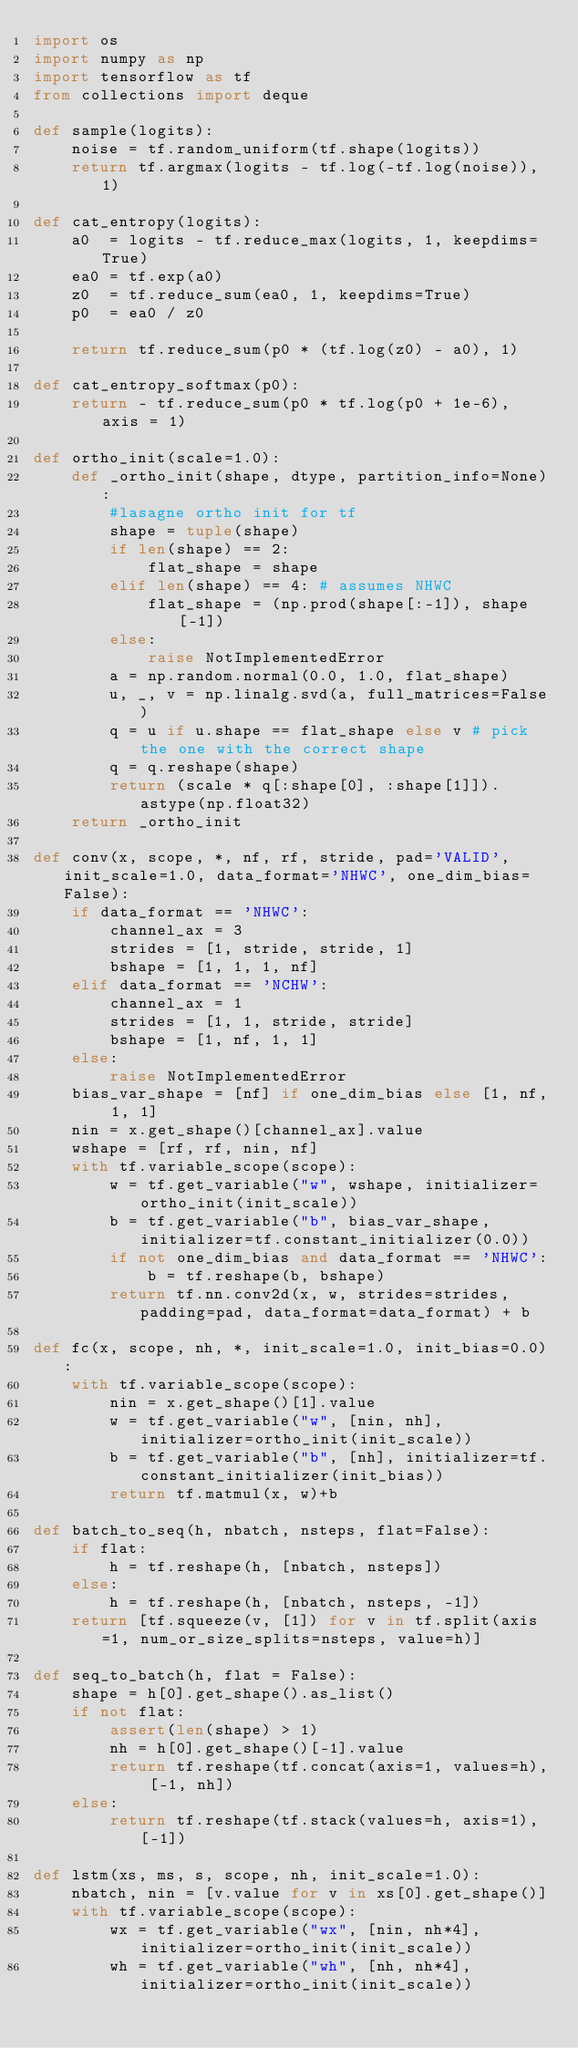<code> <loc_0><loc_0><loc_500><loc_500><_Python_>import os
import numpy as np
import tensorflow as tf
from collections import deque

def sample(logits):
    noise = tf.random_uniform(tf.shape(logits))
    return tf.argmax(logits - tf.log(-tf.log(noise)), 1)

def cat_entropy(logits):
    a0  = logits - tf.reduce_max(logits, 1, keepdims=True)
    ea0 = tf.exp(a0)
    z0  = tf.reduce_sum(ea0, 1, keepdims=True)
    p0  = ea0 / z0

    return tf.reduce_sum(p0 * (tf.log(z0) - a0), 1)

def cat_entropy_softmax(p0):
    return - tf.reduce_sum(p0 * tf.log(p0 + 1e-6), axis = 1)

def ortho_init(scale=1.0):
    def _ortho_init(shape, dtype, partition_info=None):
        #lasagne ortho init for tf
        shape = tuple(shape)
        if len(shape) == 2:
            flat_shape = shape
        elif len(shape) == 4: # assumes NHWC
            flat_shape = (np.prod(shape[:-1]), shape[-1])
        else:
            raise NotImplementedError
        a = np.random.normal(0.0, 1.0, flat_shape)
        u, _, v = np.linalg.svd(a, full_matrices=False)
        q = u if u.shape == flat_shape else v # pick the one with the correct shape
        q = q.reshape(shape)
        return (scale * q[:shape[0], :shape[1]]).astype(np.float32)
    return _ortho_init

def conv(x, scope, *, nf, rf, stride, pad='VALID', init_scale=1.0, data_format='NHWC', one_dim_bias=False):
    if data_format == 'NHWC':
        channel_ax = 3
        strides = [1, stride, stride, 1]
        bshape = [1, 1, 1, nf]
    elif data_format == 'NCHW':
        channel_ax = 1
        strides = [1, 1, stride, stride]
        bshape = [1, nf, 1, 1]
    else:
        raise NotImplementedError
    bias_var_shape = [nf] if one_dim_bias else [1, nf, 1, 1]
    nin = x.get_shape()[channel_ax].value
    wshape = [rf, rf, nin, nf]
    with tf.variable_scope(scope):
        w = tf.get_variable("w", wshape, initializer=ortho_init(init_scale))
        b = tf.get_variable("b", bias_var_shape, initializer=tf.constant_initializer(0.0))
        if not one_dim_bias and data_format == 'NHWC':
            b = tf.reshape(b, bshape)
        return tf.nn.conv2d(x, w, strides=strides, padding=pad, data_format=data_format) + b

def fc(x, scope, nh, *, init_scale=1.0, init_bias=0.0):
    with tf.variable_scope(scope):
        nin = x.get_shape()[1].value
        w = tf.get_variable("w", [nin, nh], initializer=ortho_init(init_scale))
        b = tf.get_variable("b", [nh], initializer=tf.constant_initializer(init_bias))
        return tf.matmul(x, w)+b

def batch_to_seq(h, nbatch, nsteps, flat=False):
    if flat:
        h = tf.reshape(h, [nbatch, nsteps])
    else:
        h = tf.reshape(h, [nbatch, nsteps, -1])
    return [tf.squeeze(v, [1]) for v in tf.split(axis=1, num_or_size_splits=nsteps, value=h)]

def seq_to_batch(h, flat = False):
    shape = h[0].get_shape().as_list()
    if not flat:
        assert(len(shape) > 1)
        nh = h[0].get_shape()[-1].value
        return tf.reshape(tf.concat(axis=1, values=h), [-1, nh])
    else:
        return tf.reshape(tf.stack(values=h, axis=1), [-1])

def lstm(xs, ms, s, scope, nh, init_scale=1.0):
    nbatch, nin = [v.value for v in xs[0].get_shape()]
    with tf.variable_scope(scope):
        wx = tf.get_variable("wx", [nin, nh*4], initializer=ortho_init(init_scale))
        wh = tf.get_variable("wh", [nh, nh*4], initializer=ortho_init(init_scale))</code> 